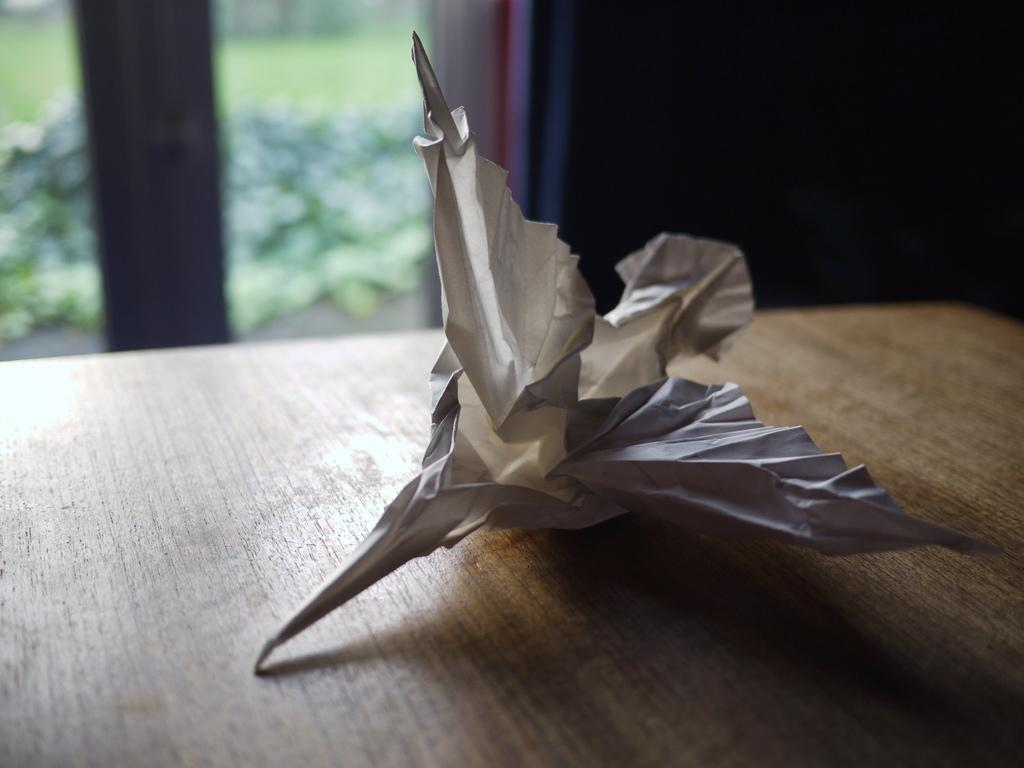What is located at the front of the image? There is a paper in the front of the image. What can be seen in the background of the image? There is a window and plants in the background of the image. What is visible through the window? Grass is visible on the ground behind the window. How many pizzas are being served by the parent in the image? There is no parent or pizzas present in the image. What type of tramp is visible in the background of the image? There is no tramp visible in the image; it features a window, plants, and grass on the ground. 